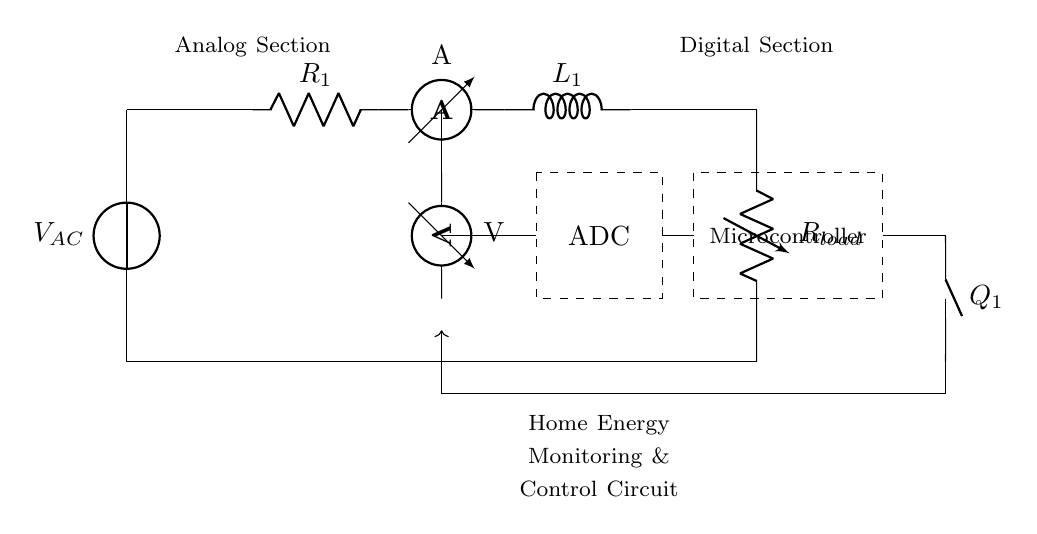What type of circuit is this? The circuit is a hybrid circuit as it combines both analog and digital components for monitoring and controlling home energy consumption.
Answer: Hybrid circuit What is the function of the ammeter in this circuit? The ammeter measures the current flowing through it, providing important information for energy monitoring.
Answer: Measures current What is the role of the ADC in this circuit? The ADC converts the analog voltage readings into digital form, allowing the microcontroller to process the information.
Answer: Converts analog to digital How is feedback controlled in this circuit? Feedback is provided via a feedback loop from the digital control output back to the analog section, facilitating continuous monitoring and adjustments based on readings.
Answer: Feedback loop What does the component labeled Q1 represent? Q1 represents a digital control output that likely controls a switch, relay, or other device in the circuit based on the microcontroller’s commands.
Answer: Digital control output What component is used for voltage measurement? The voltmeter is used to measure voltage across different points in the circuit, providing critical data for monitoring energy consumption.
Answer: Voltmeter 